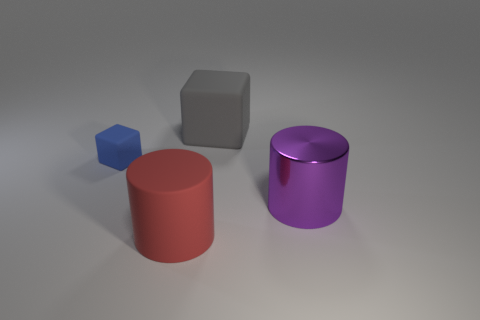Add 3 tiny blocks. How many objects exist? 7 Add 4 purple shiny balls. How many purple shiny balls exist? 4 Subtract 0 red balls. How many objects are left? 4 Subtract all large red rubber cylinders. Subtract all large blocks. How many objects are left? 2 Add 1 small matte objects. How many small matte objects are left? 2 